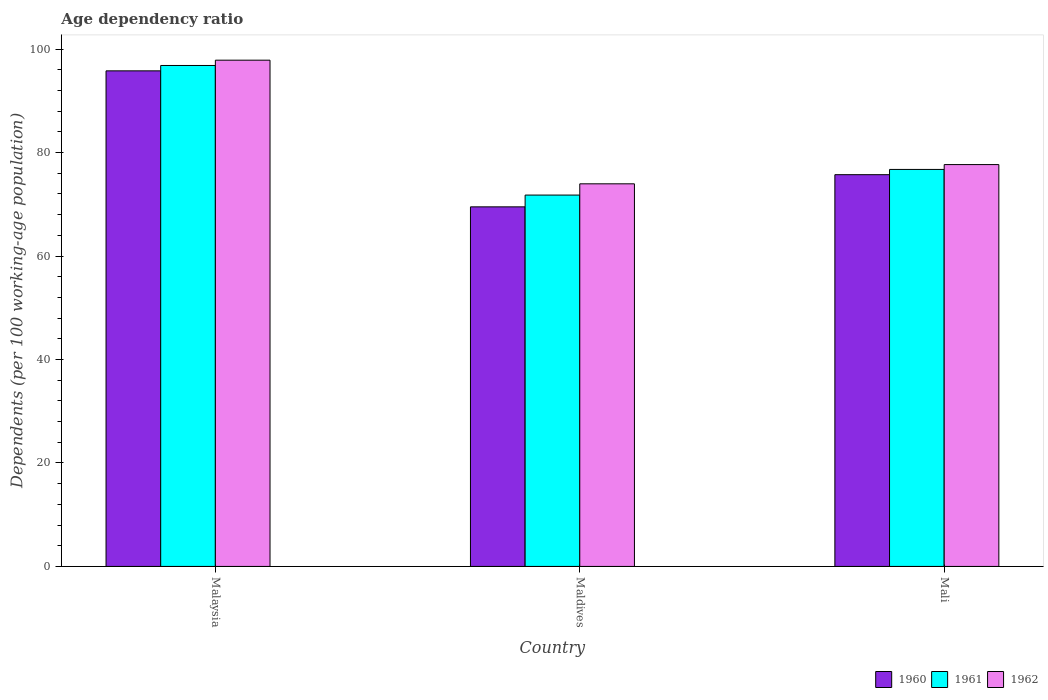How many groups of bars are there?
Provide a short and direct response. 3. Are the number of bars on each tick of the X-axis equal?
Your answer should be very brief. Yes. How many bars are there on the 3rd tick from the left?
Offer a terse response. 3. What is the label of the 2nd group of bars from the left?
Your answer should be very brief. Maldives. What is the age dependency ratio in in 1962 in Maldives?
Offer a very short reply. 73.97. Across all countries, what is the maximum age dependency ratio in in 1960?
Provide a succinct answer. 95.81. Across all countries, what is the minimum age dependency ratio in in 1962?
Your answer should be very brief. 73.97. In which country was the age dependency ratio in in 1961 maximum?
Offer a very short reply. Malaysia. In which country was the age dependency ratio in in 1961 minimum?
Provide a succinct answer. Maldives. What is the total age dependency ratio in in 1960 in the graph?
Provide a short and direct response. 241.06. What is the difference between the age dependency ratio in in 1961 in Malaysia and that in Maldives?
Keep it short and to the point. 25.05. What is the difference between the age dependency ratio in in 1960 in Malaysia and the age dependency ratio in in 1962 in Mali?
Make the answer very short. 18.12. What is the average age dependency ratio in in 1960 per country?
Give a very brief answer. 80.35. What is the difference between the age dependency ratio in of/in 1962 and age dependency ratio in of/in 1960 in Malaysia?
Make the answer very short. 2.06. In how many countries, is the age dependency ratio in in 1962 greater than 16 %?
Offer a very short reply. 3. What is the ratio of the age dependency ratio in in 1961 in Maldives to that in Mali?
Your response must be concise. 0.94. Is the age dependency ratio in in 1962 in Malaysia less than that in Maldives?
Provide a short and direct response. No. Is the difference between the age dependency ratio in in 1962 in Maldives and Mali greater than the difference between the age dependency ratio in in 1960 in Maldives and Mali?
Offer a terse response. Yes. What is the difference between the highest and the second highest age dependency ratio in in 1960?
Provide a short and direct response. 6.22. What is the difference between the highest and the lowest age dependency ratio in in 1962?
Your response must be concise. 23.9. In how many countries, is the age dependency ratio in in 1961 greater than the average age dependency ratio in in 1961 taken over all countries?
Your response must be concise. 1. Is the sum of the age dependency ratio in in 1962 in Malaysia and Mali greater than the maximum age dependency ratio in in 1961 across all countries?
Offer a terse response. Yes. What does the 3rd bar from the left in Mali represents?
Make the answer very short. 1962. What does the 1st bar from the right in Maldives represents?
Your answer should be compact. 1962. How many bars are there?
Keep it short and to the point. 9. How many countries are there in the graph?
Offer a terse response. 3. Are the values on the major ticks of Y-axis written in scientific E-notation?
Make the answer very short. No. Does the graph contain any zero values?
Provide a succinct answer. No. Where does the legend appear in the graph?
Give a very brief answer. Bottom right. What is the title of the graph?
Ensure brevity in your answer.  Age dependency ratio. What is the label or title of the X-axis?
Your answer should be compact. Country. What is the label or title of the Y-axis?
Provide a succinct answer. Dependents (per 100 working-age population). What is the Dependents (per 100 working-age population) in 1960 in Malaysia?
Give a very brief answer. 95.81. What is the Dependents (per 100 working-age population) in 1961 in Malaysia?
Provide a short and direct response. 96.85. What is the Dependents (per 100 working-age population) of 1962 in Malaysia?
Your answer should be compact. 97.87. What is the Dependents (per 100 working-age population) in 1960 in Maldives?
Give a very brief answer. 69.51. What is the Dependents (per 100 working-age population) of 1961 in Maldives?
Provide a short and direct response. 71.79. What is the Dependents (per 100 working-age population) of 1962 in Maldives?
Provide a succinct answer. 73.97. What is the Dependents (per 100 working-age population) in 1960 in Mali?
Your answer should be compact. 75.73. What is the Dependents (per 100 working-age population) in 1961 in Mali?
Ensure brevity in your answer.  76.75. What is the Dependents (per 100 working-age population) in 1962 in Mali?
Give a very brief answer. 77.69. Across all countries, what is the maximum Dependents (per 100 working-age population) of 1960?
Offer a terse response. 95.81. Across all countries, what is the maximum Dependents (per 100 working-age population) of 1961?
Offer a terse response. 96.85. Across all countries, what is the maximum Dependents (per 100 working-age population) of 1962?
Ensure brevity in your answer.  97.87. Across all countries, what is the minimum Dependents (per 100 working-age population) in 1960?
Make the answer very short. 69.51. Across all countries, what is the minimum Dependents (per 100 working-age population) in 1961?
Your response must be concise. 71.79. Across all countries, what is the minimum Dependents (per 100 working-age population) of 1962?
Your answer should be compact. 73.97. What is the total Dependents (per 100 working-age population) in 1960 in the graph?
Offer a very short reply. 241.06. What is the total Dependents (per 100 working-age population) in 1961 in the graph?
Your response must be concise. 245.39. What is the total Dependents (per 100 working-age population) in 1962 in the graph?
Offer a very short reply. 249.52. What is the difference between the Dependents (per 100 working-age population) of 1960 in Malaysia and that in Maldives?
Your response must be concise. 26.29. What is the difference between the Dependents (per 100 working-age population) in 1961 in Malaysia and that in Maldives?
Give a very brief answer. 25.05. What is the difference between the Dependents (per 100 working-age population) of 1962 in Malaysia and that in Maldives?
Ensure brevity in your answer.  23.9. What is the difference between the Dependents (per 100 working-age population) in 1960 in Malaysia and that in Mali?
Ensure brevity in your answer.  20.07. What is the difference between the Dependents (per 100 working-age population) in 1961 in Malaysia and that in Mali?
Keep it short and to the point. 20.1. What is the difference between the Dependents (per 100 working-age population) in 1962 in Malaysia and that in Mali?
Your answer should be compact. 20.18. What is the difference between the Dependents (per 100 working-age population) in 1960 in Maldives and that in Mali?
Provide a short and direct response. -6.22. What is the difference between the Dependents (per 100 working-age population) in 1961 in Maldives and that in Mali?
Offer a terse response. -4.96. What is the difference between the Dependents (per 100 working-age population) in 1962 in Maldives and that in Mali?
Provide a short and direct response. -3.72. What is the difference between the Dependents (per 100 working-age population) of 1960 in Malaysia and the Dependents (per 100 working-age population) of 1961 in Maldives?
Provide a succinct answer. 24.01. What is the difference between the Dependents (per 100 working-age population) in 1960 in Malaysia and the Dependents (per 100 working-age population) in 1962 in Maldives?
Keep it short and to the point. 21.84. What is the difference between the Dependents (per 100 working-age population) in 1961 in Malaysia and the Dependents (per 100 working-age population) in 1962 in Maldives?
Keep it short and to the point. 22.88. What is the difference between the Dependents (per 100 working-age population) in 1960 in Malaysia and the Dependents (per 100 working-age population) in 1961 in Mali?
Offer a terse response. 19.06. What is the difference between the Dependents (per 100 working-age population) of 1960 in Malaysia and the Dependents (per 100 working-age population) of 1962 in Mali?
Ensure brevity in your answer.  18.12. What is the difference between the Dependents (per 100 working-age population) in 1961 in Malaysia and the Dependents (per 100 working-age population) in 1962 in Mali?
Your answer should be very brief. 19.16. What is the difference between the Dependents (per 100 working-age population) in 1960 in Maldives and the Dependents (per 100 working-age population) in 1961 in Mali?
Provide a short and direct response. -7.24. What is the difference between the Dependents (per 100 working-age population) in 1960 in Maldives and the Dependents (per 100 working-age population) in 1962 in Mali?
Your answer should be very brief. -8.17. What is the difference between the Dependents (per 100 working-age population) in 1961 in Maldives and the Dependents (per 100 working-age population) in 1962 in Mali?
Ensure brevity in your answer.  -5.89. What is the average Dependents (per 100 working-age population) in 1960 per country?
Provide a succinct answer. 80.35. What is the average Dependents (per 100 working-age population) in 1961 per country?
Your answer should be compact. 81.8. What is the average Dependents (per 100 working-age population) in 1962 per country?
Give a very brief answer. 83.17. What is the difference between the Dependents (per 100 working-age population) of 1960 and Dependents (per 100 working-age population) of 1961 in Malaysia?
Ensure brevity in your answer.  -1.04. What is the difference between the Dependents (per 100 working-age population) of 1960 and Dependents (per 100 working-age population) of 1962 in Malaysia?
Provide a short and direct response. -2.06. What is the difference between the Dependents (per 100 working-age population) of 1961 and Dependents (per 100 working-age population) of 1962 in Malaysia?
Your answer should be compact. -1.02. What is the difference between the Dependents (per 100 working-age population) in 1960 and Dependents (per 100 working-age population) in 1961 in Maldives?
Offer a very short reply. -2.28. What is the difference between the Dependents (per 100 working-age population) in 1960 and Dependents (per 100 working-age population) in 1962 in Maldives?
Your answer should be compact. -4.45. What is the difference between the Dependents (per 100 working-age population) of 1961 and Dependents (per 100 working-age population) of 1962 in Maldives?
Your response must be concise. -2.17. What is the difference between the Dependents (per 100 working-age population) in 1960 and Dependents (per 100 working-age population) in 1961 in Mali?
Make the answer very short. -1.02. What is the difference between the Dependents (per 100 working-age population) of 1960 and Dependents (per 100 working-age population) of 1962 in Mali?
Provide a succinct answer. -1.95. What is the difference between the Dependents (per 100 working-age population) of 1961 and Dependents (per 100 working-age population) of 1962 in Mali?
Keep it short and to the point. -0.94. What is the ratio of the Dependents (per 100 working-age population) in 1960 in Malaysia to that in Maldives?
Offer a terse response. 1.38. What is the ratio of the Dependents (per 100 working-age population) in 1961 in Malaysia to that in Maldives?
Your response must be concise. 1.35. What is the ratio of the Dependents (per 100 working-age population) of 1962 in Malaysia to that in Maldives?
Your answer should be compact. 1.32. What is the ratio of the Dependents (per 100 working-age population) of 1960 in Malaysia to that in Mali?
Give a very brief answer. 1.26. What is the ratio of the Dependents (per 100 working-age population) in 1961 in Malaysia to that in Mali?
Give a very brief answer. 1.26. What is the ratio of the Dependents (per 100 working-age population) in 1962 in Malaysia to that in Mali?
Ensure brevity in your answer.  1.26. What is the ratio of the Dependents (per 100 working-age population) of 1960 in Maldives to that in Mali?
Provide a short and direct response. 0.92. What is the ratio of the Dependents (per 100 working-age population) in 1961 in Maldives to that in Mali?
Make the answer very short. 0.94. What is the ratio of the Dependents (per 100 working-age population) of 1962 in Maldives to that in Mali?
Give a very brief answer. 0.95. What is the difference between the highest and the second highest Dependents (per 100 working-age population) of 1960?
Make the answer very short. 20.07. What is the difference between the highest and the second highest Dependents (per 100 working-age population) in 1961?
Make the answer very short. 20.1. What is the difference between the highest and the second highest Dependents (per 100 working-age population) of 1962?
Ensure brevity in your answer.  20.18. What is the difference between the highest and the lowest Dependents (per 100 working-age population) in 1960?
Your answer should be compact. 26.29. What is the difference between the highest and the lowest Dependents (per 100 working-age population) in 1961?
Give a very brief answer. 25.05. What is the difference between the highest and the lowest Dependents (per 100 working-age population) of 1962?
Keep it short and to the point. 23.9. 